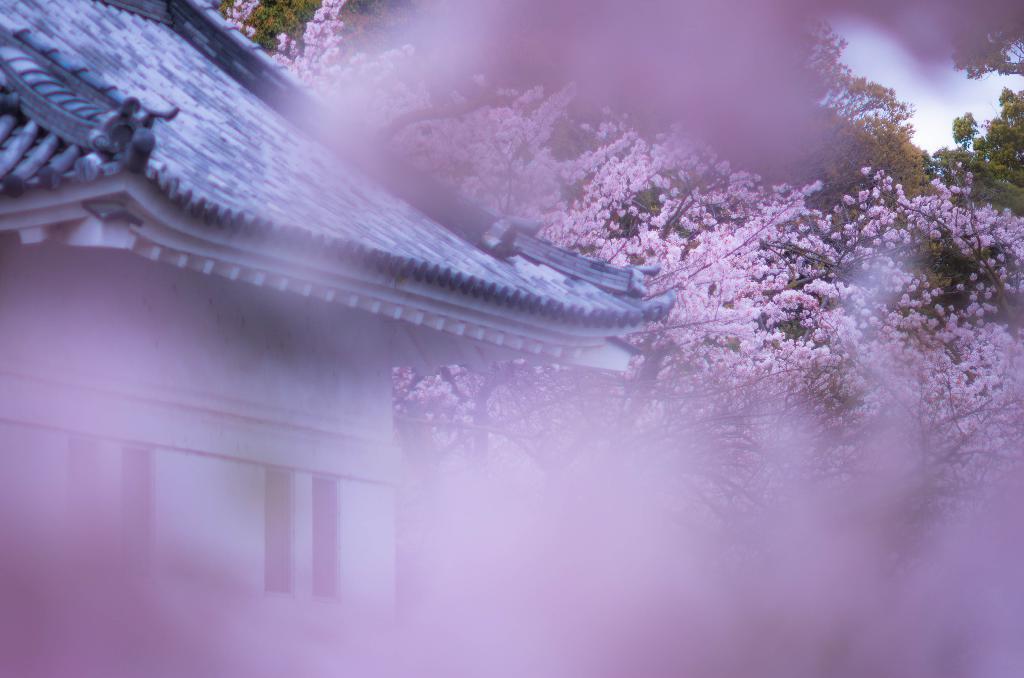In one or two sentences, can you explain what this image depicts? In this picture there is a house and there are roof tiles on the top of the house. At the back there are trees and there are pink color flowers on the tree. At the top there is sky. In the foreground image is blurry. 